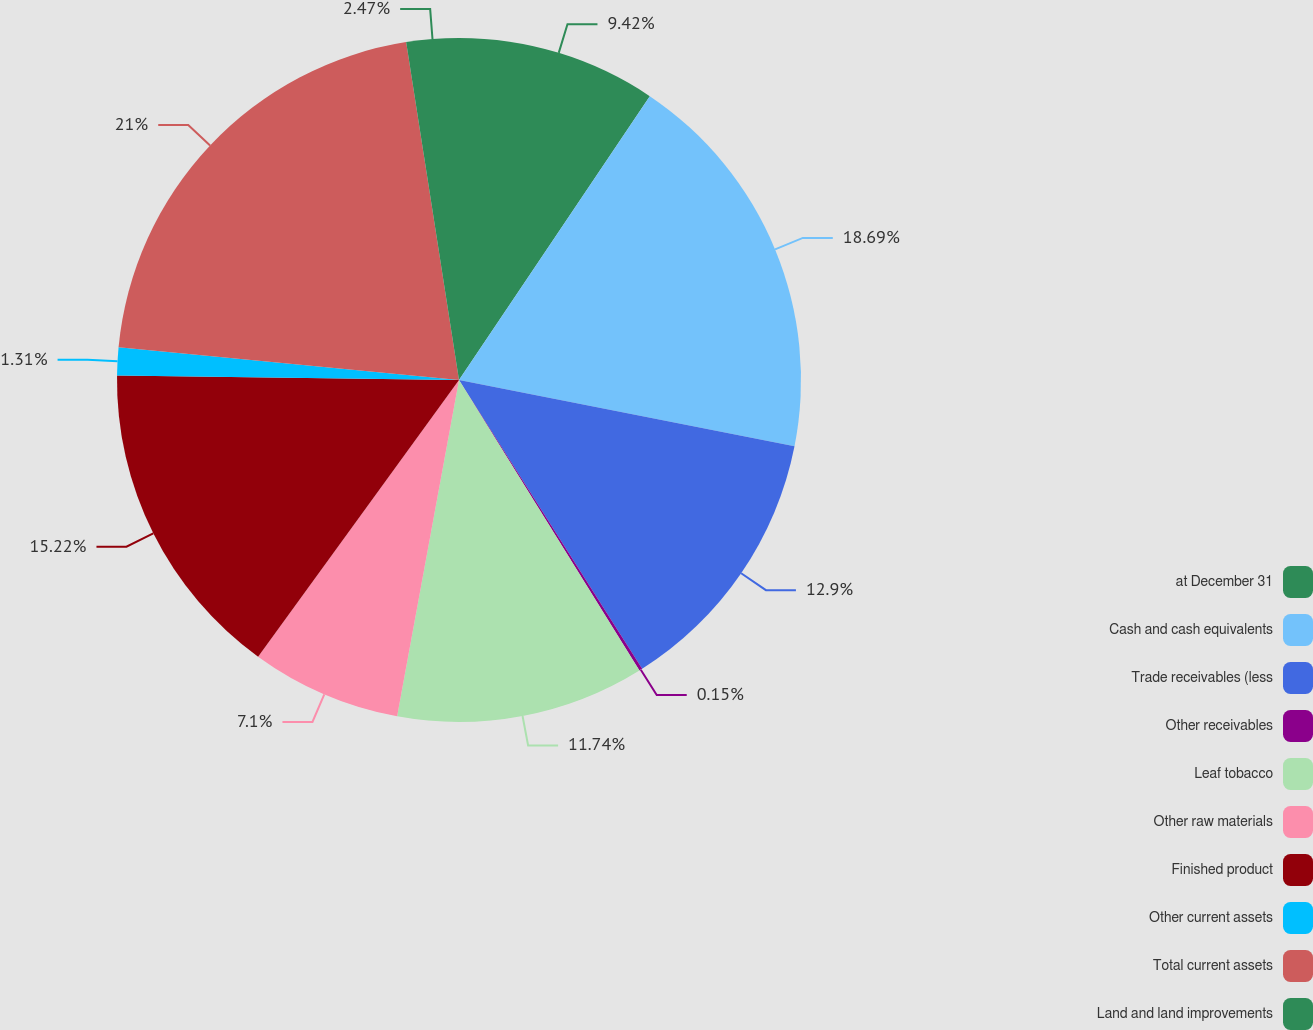<chart> <loc_0><loc_0><loc_500><loc_500><pie_chart><fcel>at December 31<fcel>Cash and cash equivalents<fcel>Trade receivables (less<fcel>Other receivables<fcel>Leaf tobacco<fcel>Other raw materials<fcel>Finished product<fcel>Other current assets<fcel>Total current assets<fcel>Land and land improvements<nl><fcel>9.42%<fcel>18.69%<fcel>12.9%<fcel>0.15%<fcel>11.74%<fcel>7.1%<fcel>15.22%<fcel>1.31%<fcel>21.01%<fcel>2.47%<nl></chart> 